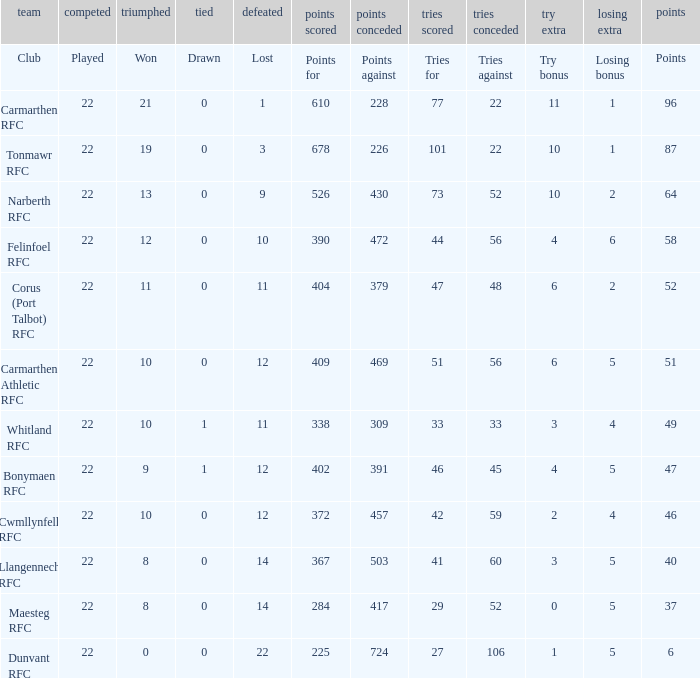Name the try bonus of points against at 430 10.0. 